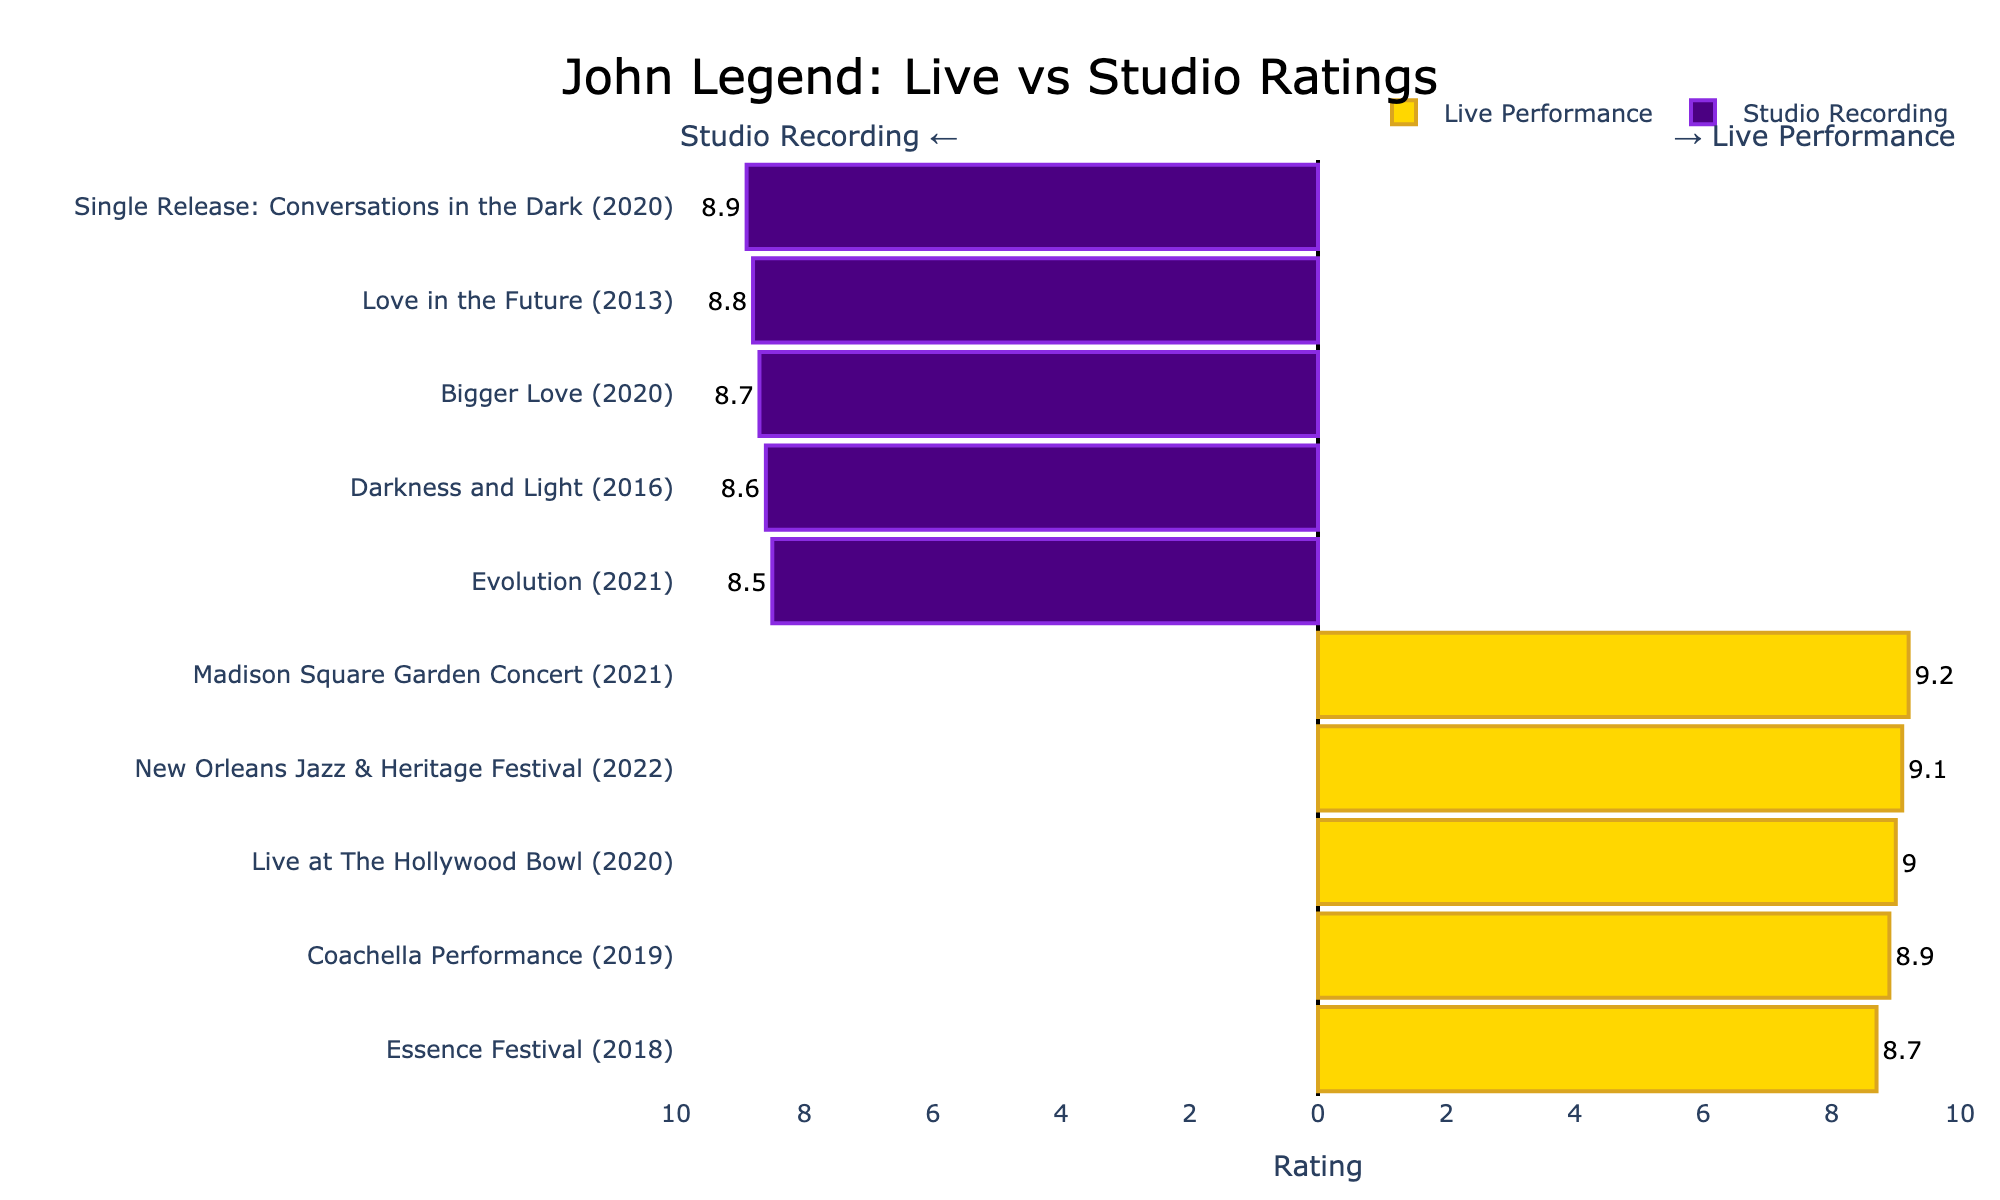what is the highest rating for John Legend’s live performances? Look at the bars representing live performances and identify the one with the highest position. The highest rating for a live performance is "Madison Square Garden Concert (2021)" with a rating of 9.2.
Answer: 9.2 How does the "Coachella Performance (2019)" compare to "Evolution (2021)"? Compare the bar heights (or lengths if bars are horizontal) for both events. The "Coachella Performance (2019)" has a rating of 8.9 while "Evolution (2021)" has a rating of 8.5. Since 8.9 is greater than 8.5, the live performance at Coachella (2019) is rated higher.
Answer: "Coachella Performance (2019)" is rated higher Which event has the lowest rating among the studio recordings? Look at the bars indicating studio recordings and find the one with the lowest rating. The shortest bar for studio recordings corresponds to "Evolution (2021)" with a rating of 8.5.
Answer: Evolution (2021) What is the average rating of John Legend's live performances? Add up all the ratings for live performances (9.2, 8.9, 9.0, 8.7, 9.1) and divide by the number of performances (5). The total is 44.9, and dividing by 5 gives an average of 8.98.
Answer: 8.98 How does the highest studio recording rating compare to the highest live performance rating? Identify the highest ratings for both categories. The highest studio recording rating is 8.9 ("Single Release: Conversations in the Dark (2020)"), and the highest live performance rating is 9.2 ("Madison Square Garden Concert (2021)"). Comparing these, the live performance has the higher rating.
Answer: Live performance has the higher rating What is the difference in ratings between "Live at The Hollywood Bowl (2020)" and "Bigger Love (2020)"? Subtract the rating for "Bigger Love (2020)" (8.7) from the rating for "Live at The Hollywood Bowl (2020)" (9.0); the difference is 0.3.
Answer: 0.3 Which category, live performances or studio recordings, has a higher average rating? Calculate the average rating for both categories. The average rating for live performances is 8.98 (as previously calculated). The average rating for studio recordings is the sum of their ratings (8.8, 8.6, 8.7, 8.5, 8.9) divided by their number (5), which results in 8.7. Therefore, live performances have a higher average rating.
Answer: Live performances 